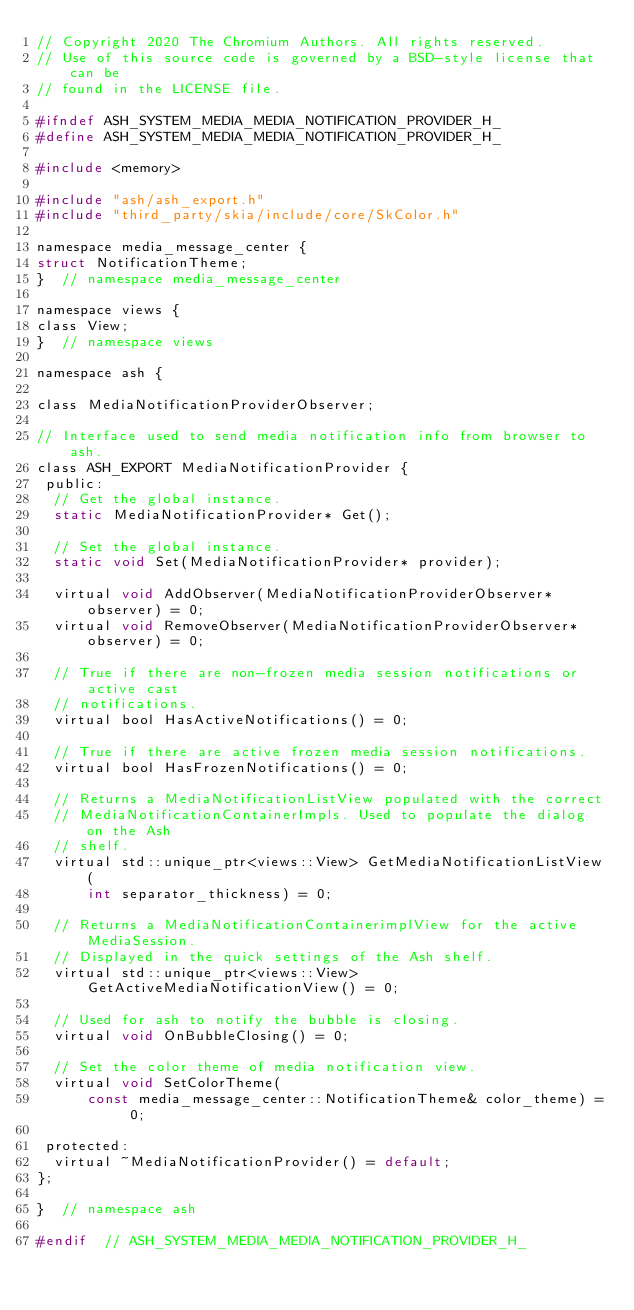<code> <loc_0><loc_0><loc_500><loc_500><_C_>// Copyright 2020 The Chromium Authors. All rights reserved.
// Use of this source code is governed by a BSD-style license that can be
// found in the LICENSE file.

#ifndef ASH_SYSTEM_MEDIA_MEDIA_NOTIFICATION_PROVIDER_H_
#define ASH_SYSTEM_MEDIA_MEDIA_NOTIFICATION_PROVIDER_H_

#include <memory>

#include "ash/ash_export.h"
#include "third_party/skia/include/core/SkColor.h"

namespace media_message_center {
struct NotificationTheme;
}  // namespace media_message_center

namespace views {
class View;
}  // namespace views

namespace ash {

class MediaNotificationProviderObserver;

// Interface used to send media notification info from browser to ash.
class ASH_EXPORT MediaNotificationProvider {
 public:
  // Get the global instance.
  static MediaNotificationProvider* Get();

  // Set the global instance.
  static void Set(MediaNotificationProvider* provider);

  virtual void AddObserver(MediaNotificationProviderObserver* observer) = 0;
  virtual void RemoveObserver(MediaNotificationProviderObserver* observer) = 0;

  // True if there are non-frozen media session notifications or active cast
  // notifications.
  virtual bool HasActiveNotifications() = 0;

  // True if there are active frozen media session notifications.
  virtual bool HasFrozenNotifications() = 0;

  // Returns a MediaNotificationListView populated with the correct
  // MediaNotificationContainerImpls. Used to populate the dialog on the Ash
  // shelf.
  virtual std::unique_ptr<views::View> GetMediaNotificationListView(
      int separator_thickness) = 0;

  // Returns a MediaNotificationContainerimplView for the active MediaSession.
  // Displayed in the quick settings of the Ash shelf.
  virtual std::unique_ptr<views::View> GetActiveMediaNotificationView() = 0;

  // Used for ash to notify the bubble is closing.
  virtual void OnBubbleClosing() = 0;

  // Set the color theme of media notification view.
  virtual void SetColorTheme(
      const media_message_center::NotificationTheme& color_theme) = 0;

 protected:
  virtual ~MediaNotificationProvider() = default;
};

}  // namespace ash

#endif  // ASH_SYSTEM_MEDIA_MEDIA_NOTIFICATION_PROVIDER_H_
</code> 